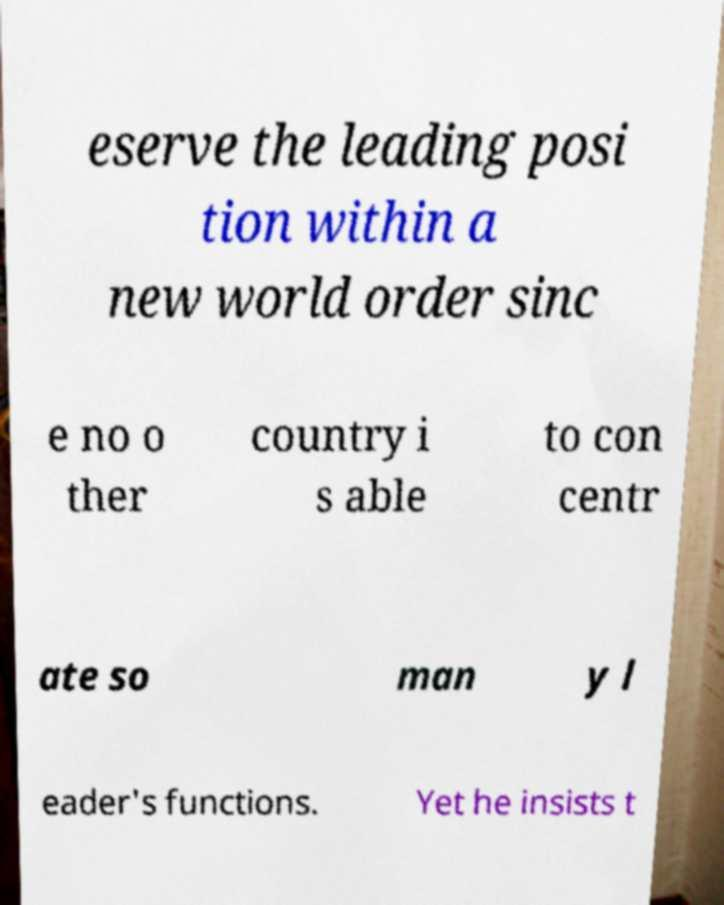Please read and relay the text visible in this image. What does it say? eserve the leading posi tion within a new world order sinc e no o ther country i s able to con centr ate so man y l eader's functions. Yet he insists t 